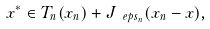<formula> <loc_0><loc_0><loc_500><loc_500>x ^ { * } \in T _ { n } ( x _ { n } ) + J _ { \ e p s _ { n } } ( x _ { n } - x ) ,</formula> 